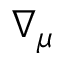<formula> <loc_0><loc_0><loc_500><loc_500>\nabla _ { \mu }</formula> 